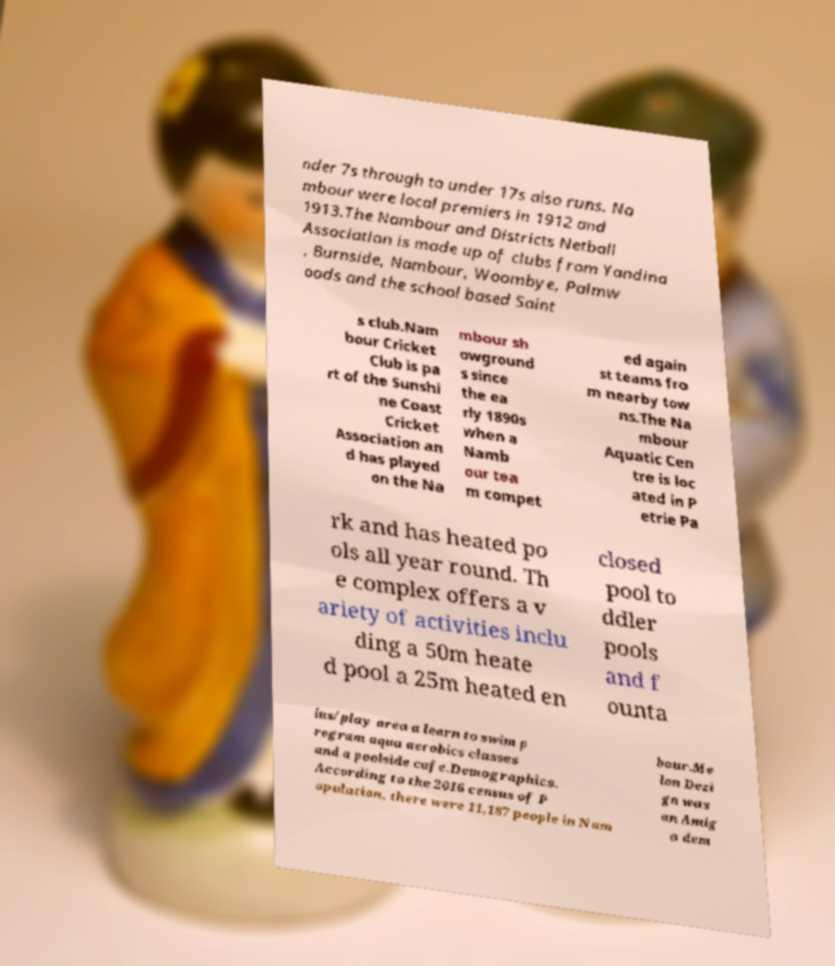Can you read and provide the text displayed in the image?This photo seems to have some interesting text. Can you extract and type it out for me? nder 7s through to under 17s also runs. Na mbour were local premiers in 1912 and 1913.The Nambour and Districts Netball Association is made up of clubs from Yandina , Burnside, Nambour, Woombye, Palmw oods and the school based Saint s club.Nam bour Cricket Club is pa rt of the Sunshi ne Coast Cricket Association an d has played on the Na mbour sh owground s since the ea rly 1890s when a Namb our tea m compet ed again st teams fro m nearby tow ns.The Na mbour Aquatic Cen tre is loc ated in P etrie Pa rk and has heated po ols all year round. Th e complex offers a v ariety of activities inclu ding a 50m heate d pool a 25m heated en closed pool to ddler pools and f ounta ins/play area a learn to swim p rogram aqua aerobics classes and a poolside cafe.Demographics. According to the 2016 census of P opulation, there were 11,187 people in Nam bour.Me lon Dezi gn was an Amig a dem 